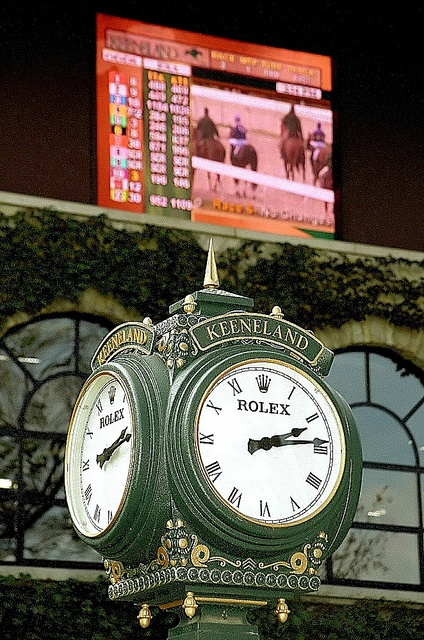Describe the objects in this image and their specific colors. I can see clock in black, white, gray, and darkgreen tones, clock in black, white, darkgray, beige, and gray tones, horse in black, maroon, lightpink, brown, and purple tones, horse in black, maroon, brown, and lightpink tones, and horse in black, maroon, brown, and salmon tones in this image. 